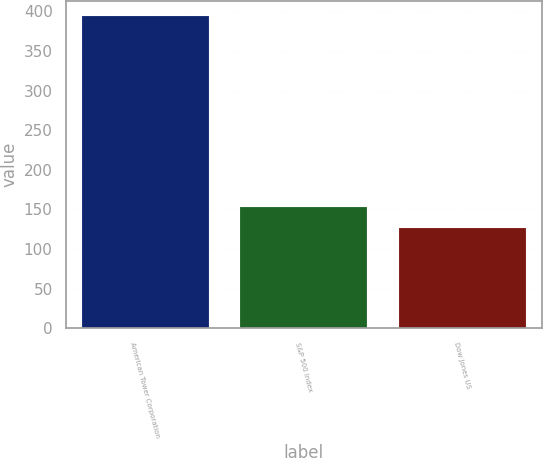<chart> <loc_0><loc_0><loc_500><loc_500><bar_chart><fcel>American Tower Corporation<fcel>S&P 500 Index<fcel>Dow Jones US<nl><fcel>393.72<fcel>153.31<fcel>126.6<nl></chart> 